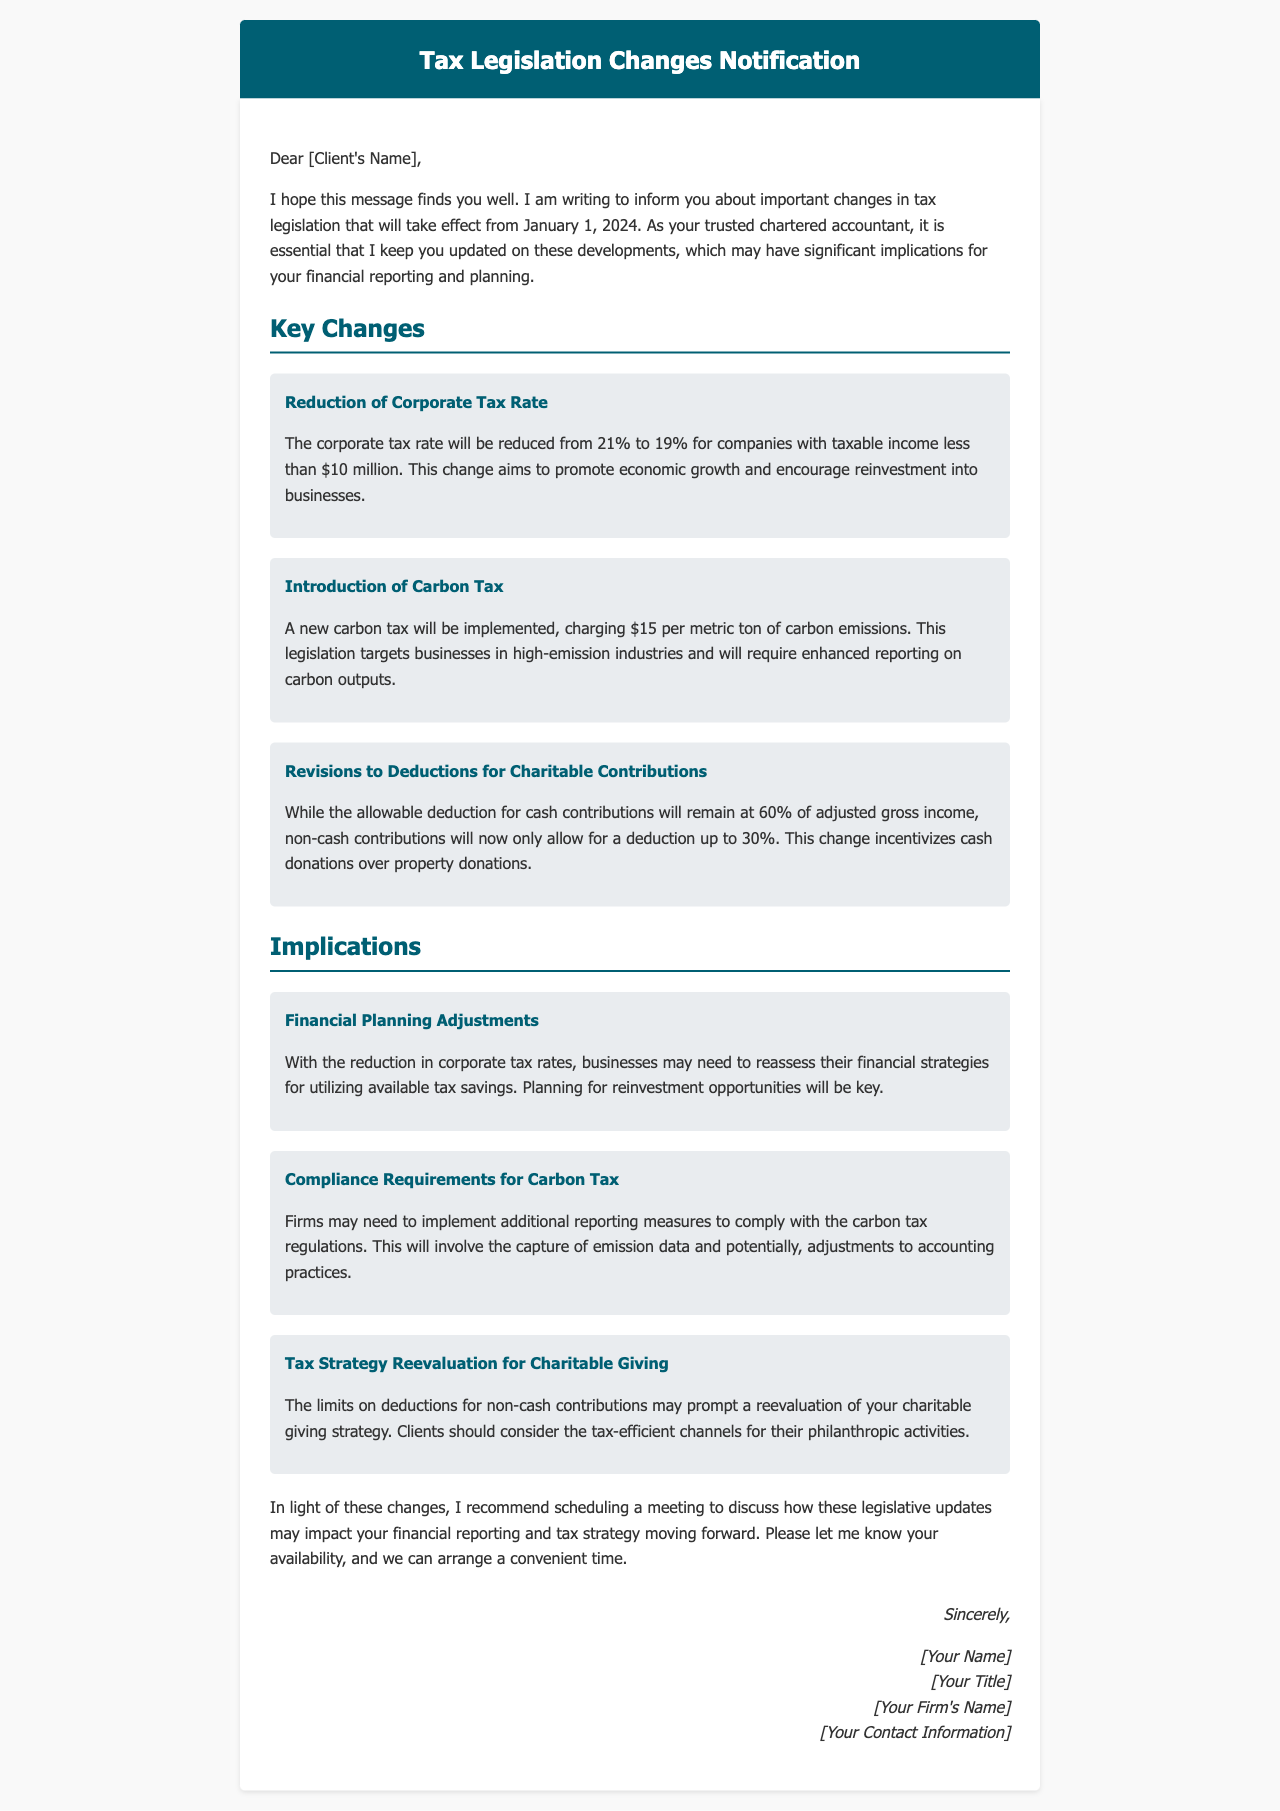what is the effective date of the new tax legislation? The effective date of the new tax legislation is mentioned as January 1, 2024.
Answer: January 1, 2024 what is the new corporate tax rate for companies with taxable income less than $10 million? The new corporate tax rate is specified as 19% for eligible companies.
Answer: 19% how much will the new carbon tax charge per metric ton of carbon emissions? The new carbon tax is stated to charge $15 per metric ton of carbon emissions.
Answer: $15 what is the allowable deduction percentage for non-cash contributions after the revisions? The allowable deduction for non-cash contributions is noted as 30% of adjusted gross income.
Answer: 30% what financial strategy adjustment is recommended due to the reduction in corporate tax rates? The document suggests businesses need to reassess their financial strategies for utilizing available tax savings.
Answer: Reassess financial strategies what additional compliance requirement is mentioned for the carbon tax? Firms may need to implement additional reporting measures to comply with carbon tax regulations, including capturing emission data.
Answer: Additional reporting measures what tax strategy reevaluation is suggested concerning charitable giving? Clients should consider reevaluating their charitable giving strategy due to limits on deductions for non-cash contributions.
Answer: Reevaluating charitable giving strategy how does the letter conclude regarding scheduling a meeting? The letter recommends scheduling a meeting to discuss the impact of legislative updates on financial reporting and tax strategy.
Answer: Scheduling a meeting 